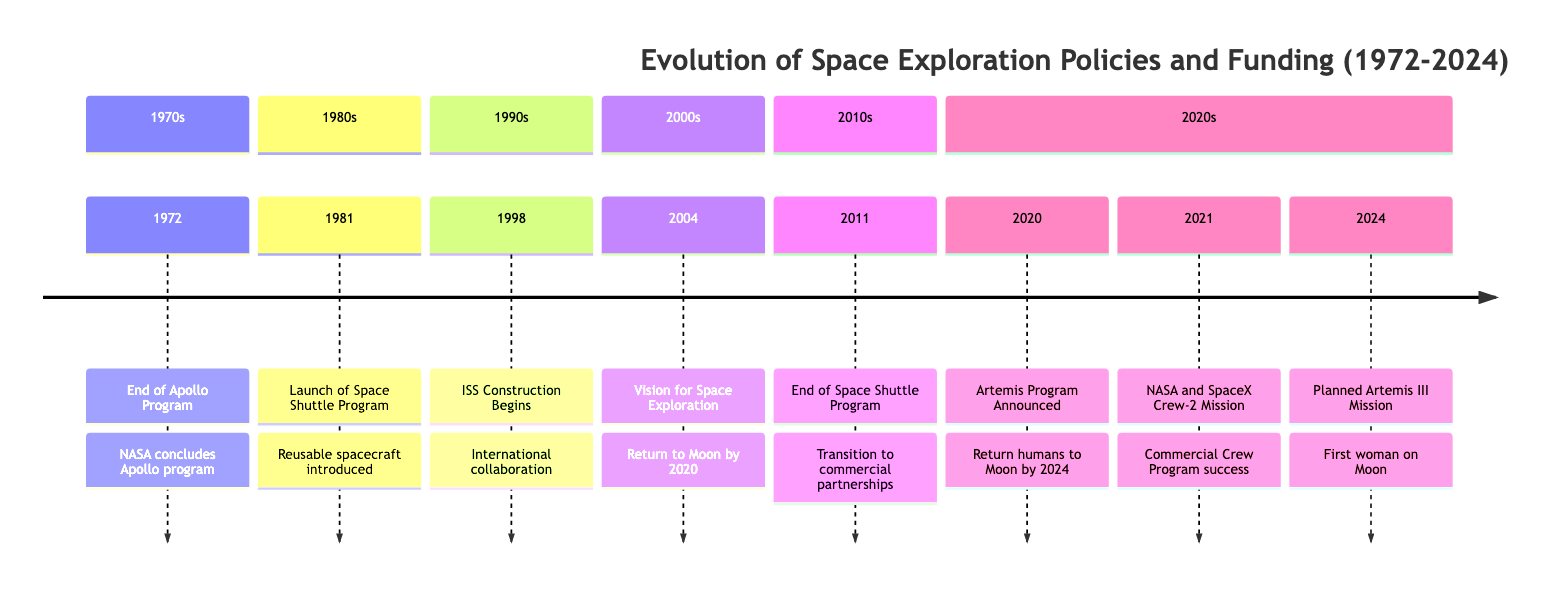What event marks the end of the Apollo program? The diagram clearly indicates that the event listed for 1972 is the "End of Apollo Program," which specifies that NASA concluded the Apollo program with Apollo 17.
Answer: End of Apollo Program In what year did NASA begin the Space Shuttle Program? From the diagram, we can see that the launch of the Space Shuttle Program is marked in 1981. It is directly labeled as a key event in that year.
Answer: 1981 What major international project began in 1998? The diagram shows that in 1998, construction of the International Space Station (ISS) began, indicating significant international collaboration.
Answer: International Space Station (ISS) Construction Begins What was the primary focus of U.S. policy in 2004? According to the diagram, the event in 2004 involves President Bush's Vision for Space Exploration, specifically emphasizing returning humans to the Moon by 2020. This indicates a clear shift in policy focus.
Answer: Returning humans to the Moon by 2020 What was the main outcome of the 2011 event? The diagram states that in 2011, the End of the Space Shuttle Program occurred, marking a transition to commercial partnerships for ISS transportation, which illustrates a significant change in NASA's operational dynamics.
Answer: Transition to commercial partnerships Which mission planned for 2024 aims to land the first woman on the Moon? The timeline specifies that the Artemis III mission is planned for 2024, and it explicitly states that the mission targets landing 'the first woman and the next man' on the lunar surface. This detail is clear in the description provided for that year.
Answer: Artemis III Mission What significant partnership was demonstrated in 2021? The diagram illustrates that in 2021, NASA and SpaceX successfully launched the Crew-2 mission as part of the Commercial Crew Program, highlighting the role of private companies in human spaceflight.
Answer: NASA and SpaceX Crew-2 Mission How many distinct sections are represented in this timeline? By analyzing the diagram, I can count six sections representing different decades from the 1970s to the 2020s, which organizes events chronologically and thematically.
Answer: 6 What type of space vehicle system was introduced in 1981? The timeline indicates that in 1981, the launch of the Space Shuttle Program introduced reusable spacecraft, significantly changing the logistics and economics of space missions.
Answer: Reusable spacecraft 